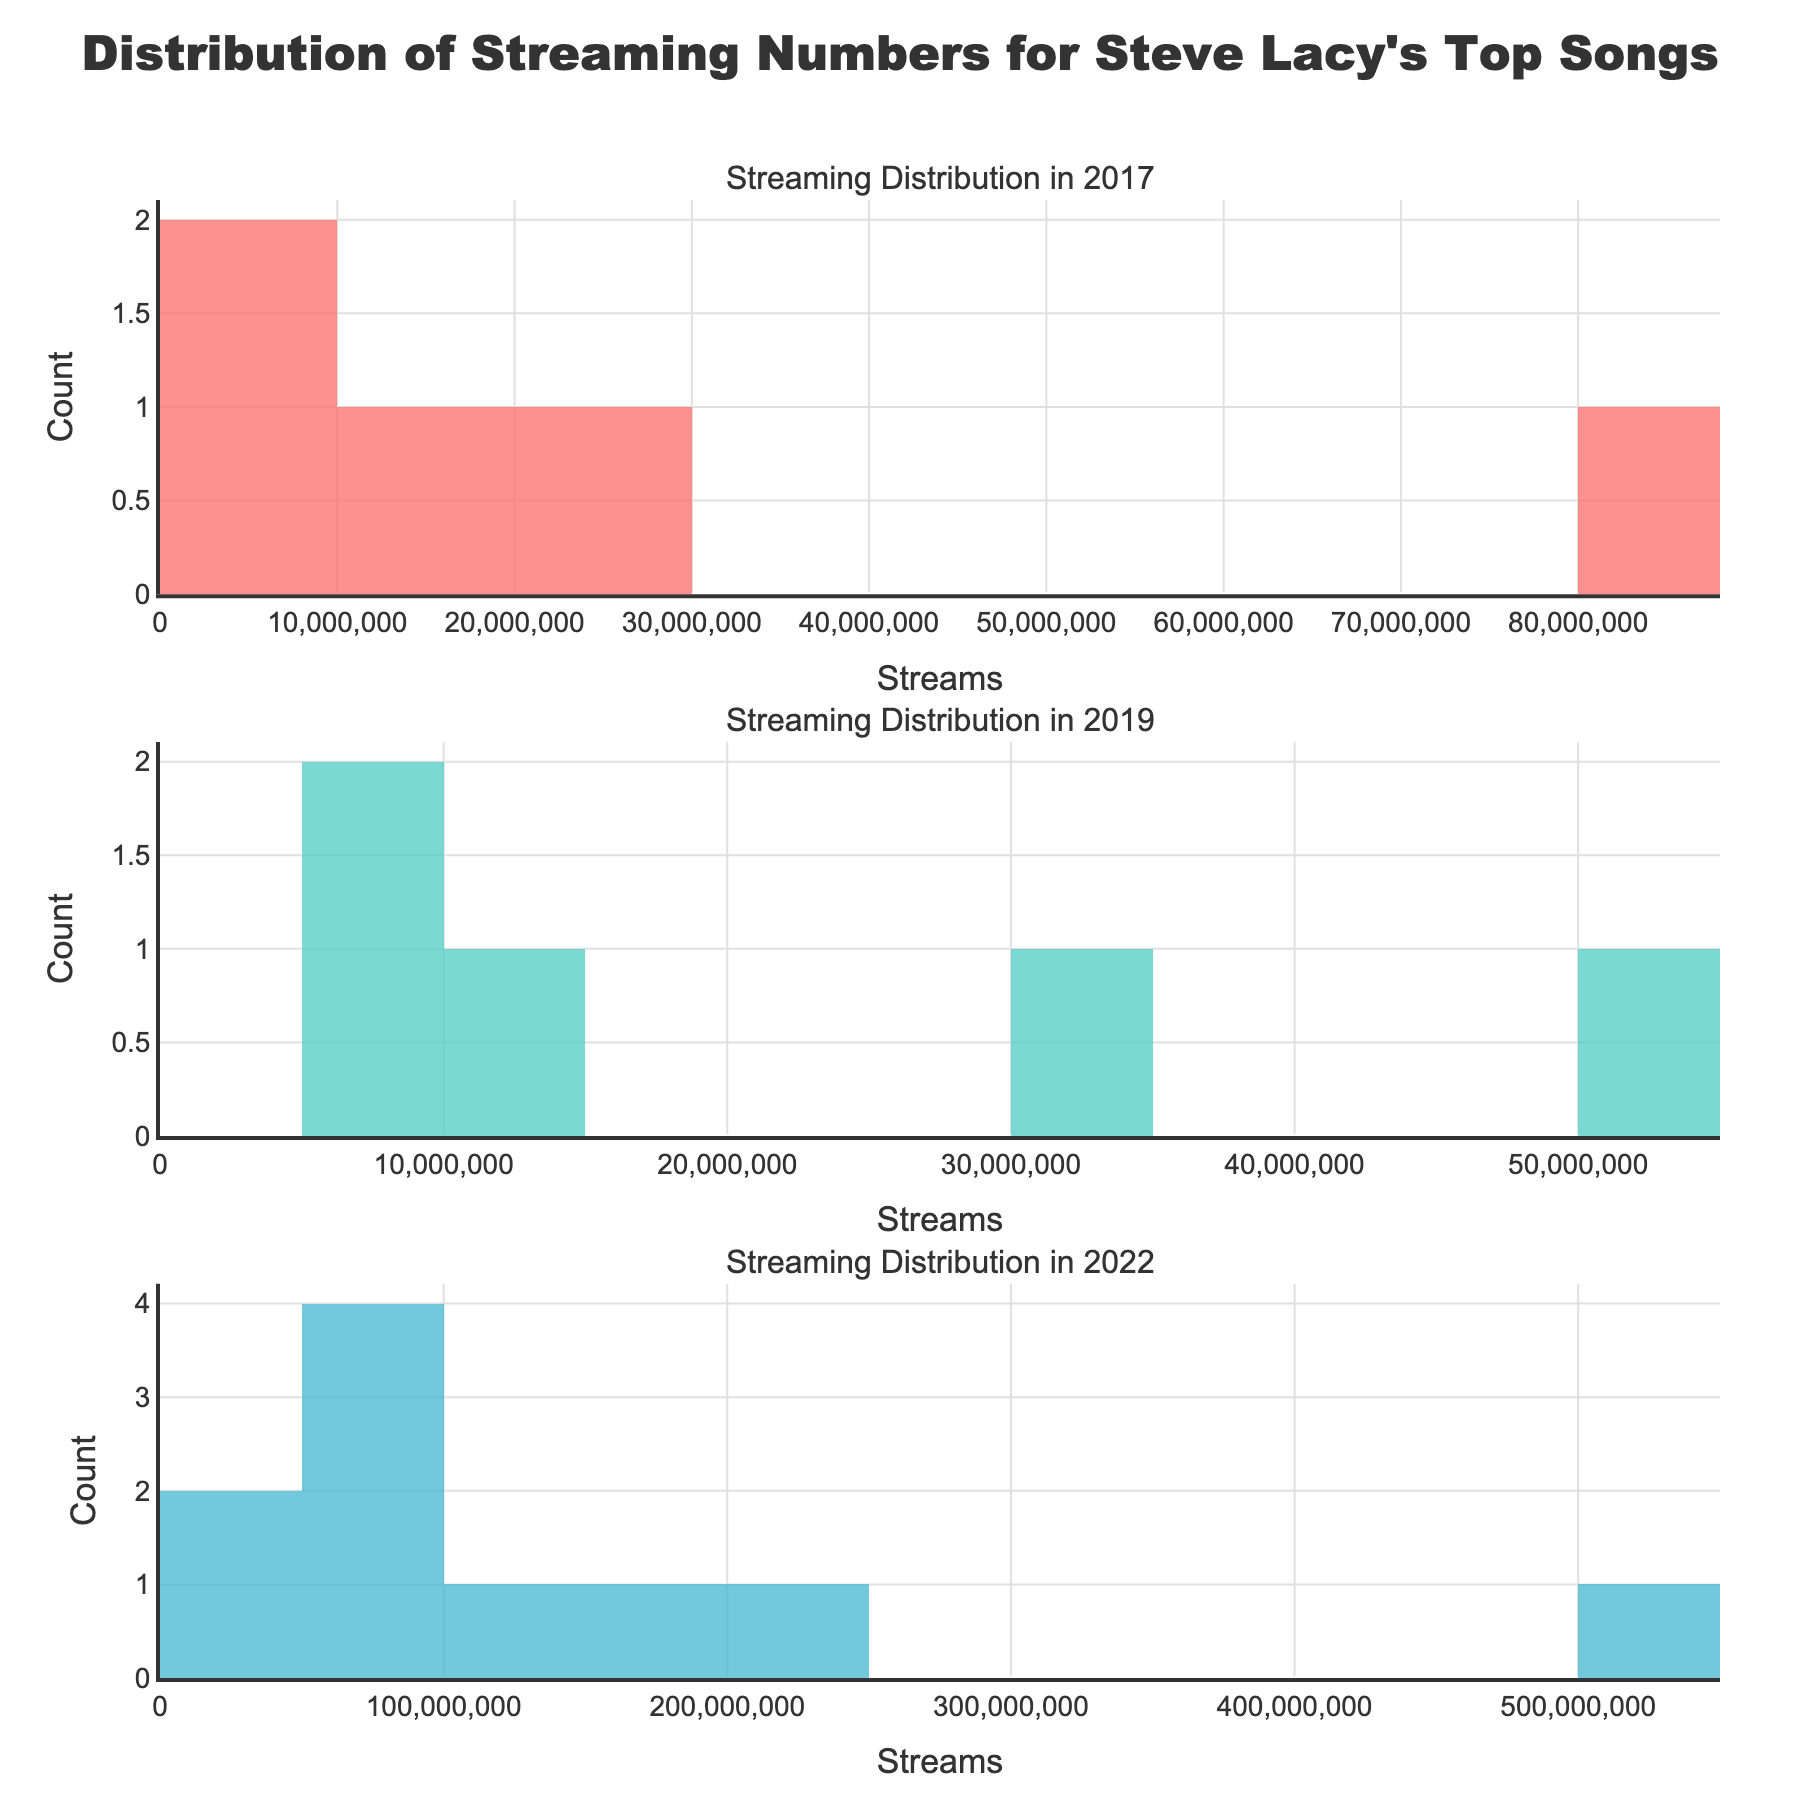Which year has the song with the highest number of streams? The year with the highest number of streams can be identified by finding the tallest bar on the histograms. The highest streaming number is 500,000,000 in 2022.
Answer: 2022 How many songs from 2017 have more than 10,000,000 streams? To find the number of songs with more than 10,000,000 streams in 2017, look at the bars in the 2017 histogram that are above 10,000,000 and count them. There are 3 songs above this threshold.
Answer: 3 What is the range of the streaming numbers for songs released in 2019? The range is the difference between the maximum and minimum streaming numbers shown in the histogram for 2019. The maximum is 50,000,000 and the minimum is 5,000,000. So, the range is 50,000,000 - 5,000,000 = 45,000,000
Answer: 45,000,000 Which year has the most evenly distributed streaming numbers for its songs? Look at the histograms to see which year has bars that appear to be of similar height, indicating a more even distribution. The histogram for 2017 shows more evenly distributed bars compared to other years.
Answer: 2017 Are there more songs with streams over 20,000,000 in 2017 or 2022? Count the bars representing more than 20,000,000 streams in 2017 and 2022. In 2017, there are 2 songs, while in 2022, there are 8 songs.
Answer: 2022 Which year has the highest count of songs between 30,000,000 and 40,000,000 streams? Count the bars in the range of 30,000,000 to 40,000,000 for each year. Only 2022 has a count in this range with one bar representing 1 song.
Answer: 2022 What is the median number of streams for songs released in 2022? To find the median, list the stream numbers for 2022, sort them, and pick the middle value. Sorted streams: [30,000,000, 40,000,000, 50,000,000, 60,000,000, 70,000,000, 80,000,000, 100,000,000, 150,000,000, 200,000,000, 500,000,000]. The middle value is 80,000,000.
Answer: 80,000,000 How does the streaming count for the most popular song in 2019 compare to the least popular song in 2022? Identify the highest and lowest bars for 2019 and 2022. The most popular song in 2019 has 50,000,000 streams, and the least popular song in 2022 has 30,000,000 streams. 50,000,000 - 30,000,000 = 20,000,000 more for the 2019 song.
Answer: 20,000,000 more Which year shows a larger spread of streaming numbers? Compare the range in the histograms: 2017 (74,000,000), 2019 (45,000,000), 2022 (470,000,000). The largest range is in 2022.
Answer: 2022 